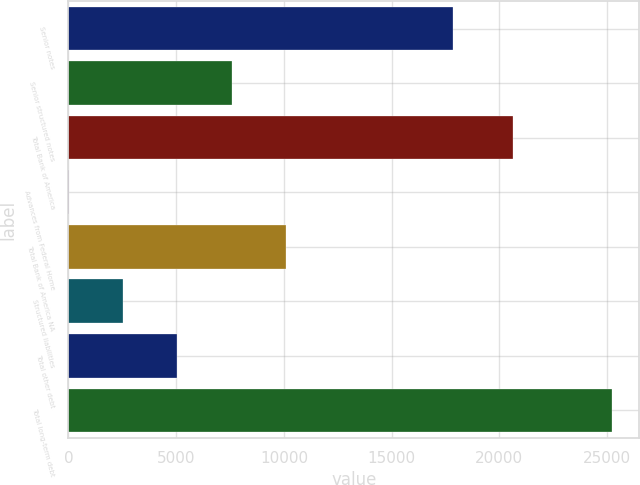Convert chart. <chart><loc_0><loc_0><loc_500><loc_500><bar_chart><fcel>Senior notes<fcel>Senior structured notes<fcel>Total Bank of America<fcel>Advances from Federal Home<fcel>Total Bank of America NA<fcel>Structured liabilities<fcel>Total other debt<fcel>Total long-term debt<nl><fcel>17858<fcel>7577.6<fcel>20630<fcel>14<fcel>10098.8<fcel>2535.2<fcel>5056.4<fcel>25226<nl></chart> 